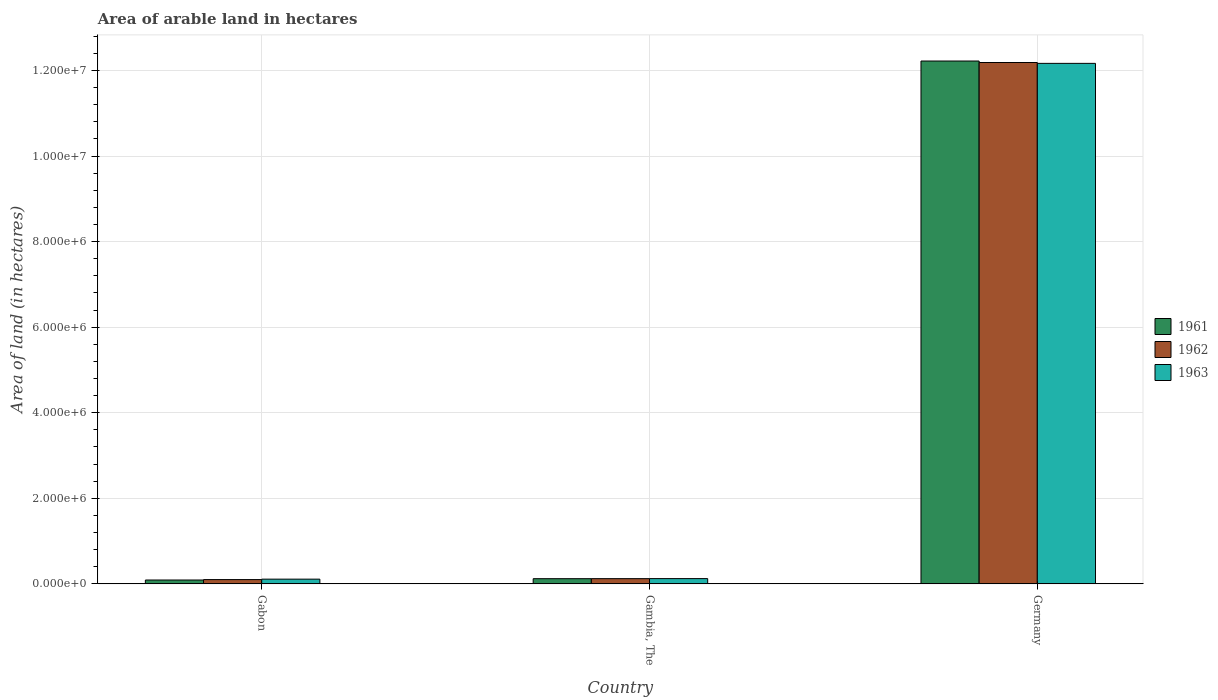What is the label of the 2nd group of bars from the left?
Make the answer very short. Gambia, The. In how many cases, is the number of bars for a given country not equal to the number of legend labels?
Your response must be concise. 0. What is the total arable land in 1962 in Gambia, The?
Provide a succinct answer. 1.22e+05. Across all countries, what is the maximum total arable land in 1963?
Offer a very short reply. 1.22e+07. In which country was the total arable land in 1963 maximum?
Ensure brevity in your answer.  Germany. In which country was the total arable land in 1963 minimum?
Give a very brief answer. Gabon. What is the total total arable land in 1962 in the graph?
Make the answer very short. 1.24e+07. What is the difference between the total arable land in 1961 in Gabon and that in Gambia, The?
Keep it short and to the point. -3.10e+04. What is the difference between the total arable land in 1962 in Gambia, The and the total arable land in 1961 in Gabon?
Provide a short and direct response. 3.20e+04. What is the average total arable land in 1963 per country?
Your response must be concise. 4.13e+06. In how many countries, is the total arable land in 1962 greater than 6000000 hectares?
Offer a terse response. 1. What is the ratio of the total arable land in 1963 in Gambia, The to that in Germany?
Your response must be concise. 0.01. Is the total arable land in 1961 in Gabon less than that in Germany?
Keep it short and to the point. Yes. What is the difference between the highest and the second highest total arable land in 1962?
Keep it short and to the point. 1.21e+07. What is the difference between the highest and the lowest total arable land in 1963?
Keep it short and to the point. 1.21e+07. In how many countries, is the total arable land in 1963 greater than the average total arable land in 1963 taken over all countries?
Make the answer very short. 1. What does the 1st bar from the left in Germany represents?
Your response must be concise. 1961. What does the 2nd bar from the right in Gabon represents?
Offer a terse response. 1962. Is it the case that in every country, the sum of the total arable land in 1961 and total arable land in 1962 is greater than the total arable land in 1963?
Make the answer very short. Yes. What is the difference between two consecutive major ticks on the Y-axis?
Your answer should be compact. 2.00e+06. What is the title of the graph?
Your answer should be very brief. Area of arable land in hectares. Does "1996" appear as one of the legend labels in the graph?
Give a very brief answer. No. What is the label or title of the Y-axis?
Give a very brief answer. Area of land (in hectares). What is the Area of land (in hectares) in 1961 in Gabon?
Provide a succinct answer. 9.00e+04. What is the Area of land (in hectares) in 1961 in Gambia, The?
Your answer should be very brief. 1.21e+05. What is the Area of land (in hectares) in 1962 in Gambia, The?
Offer a very short reply. 1.22e+05. What is the Area of land (in hectares) in 1963 in Gambia, The?
Provide a succinct answer. 1.23e+05. What is the Area of land (in hectares) of 1961 in Germany?
Your response must be concise. 1.22e+07. What is the Area of land (in hectares) in 1962 in Germany?
Ensure brevity in your answer.  1.22e+07. What is the Area of land (in hectares) of 1963 in Germany?
Offer a terse response. 1.22e+07. Across all countries, what is the maximum Area of land (in hectares) of 1961?
Your answer should be very brief. 1.22e+07. Across all countries, what is the maximum Area of land (in hectares) in 1962?
Provide a short and direct response. 1.22e+07. Across all countries, what is the maximum Area of land (in hectares) of 1963?
Make the answer very short. 1.22e+07. Across all countries, what is the minimum Area of land (in hectares) in 1961?
Provide a succinct answer. 9.00e+04. Across all countries, what is the minimum Area of land (in hectares) of 1962?
Your answer should be very brief. 1.00e+05. What is the total Area of land (in hectares) in 1961 in the graph?
Keep it short and to the point. 1.24e+07. What is the total Area of land (in hectares) of 1962 in the graph?
Your answer should be compact. 1.24e+07. What is the total Area of land (in hectares) in 1963 in the graph?
Your response must be concise. 1.24e+07. What is the difference between the Area of land (in hectares) in 1961 in Gabon and that in Gambia, The?
Provide a succinct answer. -3.10e+04. What is the difference between the Area of land (in hectares) in 1962 in Gabon and that in Gambia, The?
Offer a very short reply. -2.20e+04. What is the difference between the Area of land (in hectares) of 1963 in Gabon and that in Gambia, The?
Give a very brief answer. -1.30e+04. What is the difference between the Area of land (in hectares) in 1961 in Gabon and that in Germany?
Provide a short and direct response. -1.21e+07. What is the difference between the Area of land (in hectares) of 1962 in Gabon and that in Germany?
Offer a terse response. -1.21e+07. What is the difference between the Area of land (in hectares) of 1963 in Gabon and that in Germany?
Offer a very short reply. -1.21e+07. What is the difference between the Area of land (in hectares) of 1961 in Gambia, The and that in Germany?
Give a very brief answer. -1.21e+07. What is the difference between the Area of land (in hectares) of 1962 in Gambia, The and that in Germany?
Your answer should be very brief. -1.21e+07. What is the difference between the Area of land (in hectares) in 1963 in Gambia, The and that in Germany?
Keep it short and to the point. -1.20e+07. What is the difference between the Area of land (in hectares) in 1961 in Gabon and the Area of land (in hectares) in 1962 in Gambia, The?
Provide a succinct answer. -3.20e+04. What is the difference between the Area of land (in hectares) of 1961 in Gabon and the Area of land (in hectares) of 1963 in Gambia, The?
Provide a short and direct response. -3.30e+04. What is the difference between the Area of land (in hectares) in 1962 in Gabon and the Area of land (in hectares) in 1963 in Gambia, The?
Ensure brevity in your answer.  -2.30e+04. What is the difference between the Area of land (in hectares) of 1961 in Gabon and the Area of land (in hectares) of 1962 in Germany?
Provide a short and direct response. -1.21e+07. What is the difference between the Area of land (in hectares) of 1961 in Gabon and the Area of land (in hectares) of 1963 in Germany?
Make the answer very short. -1.21e+07. What is the difference between the Area of land (in hectares) of 1962 in Gabon and the Area of land (in hectares) of 1963 in Germany?
Offer a terse response. -1.21e+07. What is the difference between the Area of land (in hectares) of 1961 in Gambia, The and the Area of land (in hectares) of 1962 in Germany?
Your response must be concise. -1.21e+07. What is the difference between the Area of land (in hectares) in 1961 in Gambia, The and the Area of land (in hectares) in 1963 in Germany?
Your response must be concise. -1.20e+07. What is the difference between the Area of land (in hectares) of 1962 in Gambia, The and the Area of land (in hectares) of 1963 in Germany?
Offer a terse response. -1.20e+07. What is the average Area of land (in hectares) in 1961 per country?
Provide a short and direct response. 4.14e+06. What is the average Area of land (in hectares) in 1962 per country?
Ensure brevity in your answer.  4.14e+06. What is the average Area of land (in hectares) of 1963 per country?
Provide a short and direct response. 4.13e+06. What is the difference between the Area of land (in hectares) in 1961 and Area of land (in hectares) in 1963 in Gabon?
Offer a terse response. -2.00e+04. What is the difference between the Area of land (in hectares) in 1961 and Area of land (in hectares) in 1962 in Gambia, The?
Give a very brief answer. -1000. What is the difference between the Area of land (in hectares) of 1961 and Area of land (in hectares) of 1963 in Gambia, The?
Keep it short and to the point. -2000. What is the difference between the Area of land (in hectares) of 1962 and Area of land (in hectares) of 1963 in Gambia, The?
Your response must be concise. -1000. What is the difference between the Area of land (in hectares) in 1961 and Area of land (in hectares) in 1962 in Germany?
Make the answer very short. 3.50e+04. What is the difference between the Area of land (in hectares) in 1961 and Area of land (in hectares) in 1963 in Germany?
Make the answer very short. 5.50e+04. What is the difference between the Area of land (in hectares) in 1962 and Area of land (in hectares) in 1963 in Germany?
Your answer should be very brief. 2.00e+04. What is the ratio of the Area of land (in hectares) of 1961 in Gabon to that in Gambia, The?
Provide a succinct answer. 0.74. What is the ratio of the Area of land (in hectares) of 1962 in Gabon to that in Gambia, The?
Ensure brevity in your answer.  0.82. What is the ratio of the Area of land (in hectares) in 1963 in Gabon to that in Gambia, The?
Your answer should be very brief. 0.89. What is the ratio of the Area of land (in hectares) of 1961 in Gabon to that in Germany?
Keep it short and to the point. 0.01. What is the ratio of the Area of land (in hectares) of 1962 in Gabon to that in Germany?
Keep it short and to the point. 0.01. What is the ratio of the Area of land (in hectares) in 1963 in Gabon to that in Germany?
Keep it short and to the point. 0.01. What is the ratio of the Area of land (in hectares) of 1961 in Gambia, The to that in Germany?
Provide a short and direct response. 0.01. What is the ratio of the Area of land (in hectares) of 1963 in Gambia, The to that in Germany?
Your answer should be very brief. 0.01. What is the difference between the highest and the second highest Area of land (in hectares) of 1961?
Keep it short and to the point. 1.21e+07. What is the difference between the highest and the second highest Area of land (in hectares) in 1962?
Your answer should be compact. 1.21e+07. What is the difference between the highest and the second highest Area of land (in hectares) of 1963?
Your answer should be compact. 1.20e+07. What is the difference between the highest and the lowest Area of land (in hectares) of 1961?
Offer a very short reply. 1.21e+07. What is the difference between the highest and the lowest Area of land (in hectares) in 1962?
Keep it short and to the point. 1.21e+07. What is the difference between the highest and the lowest Area of land (in hectares) in 1963?
Provide a short and direct response. 1.21e+07. 